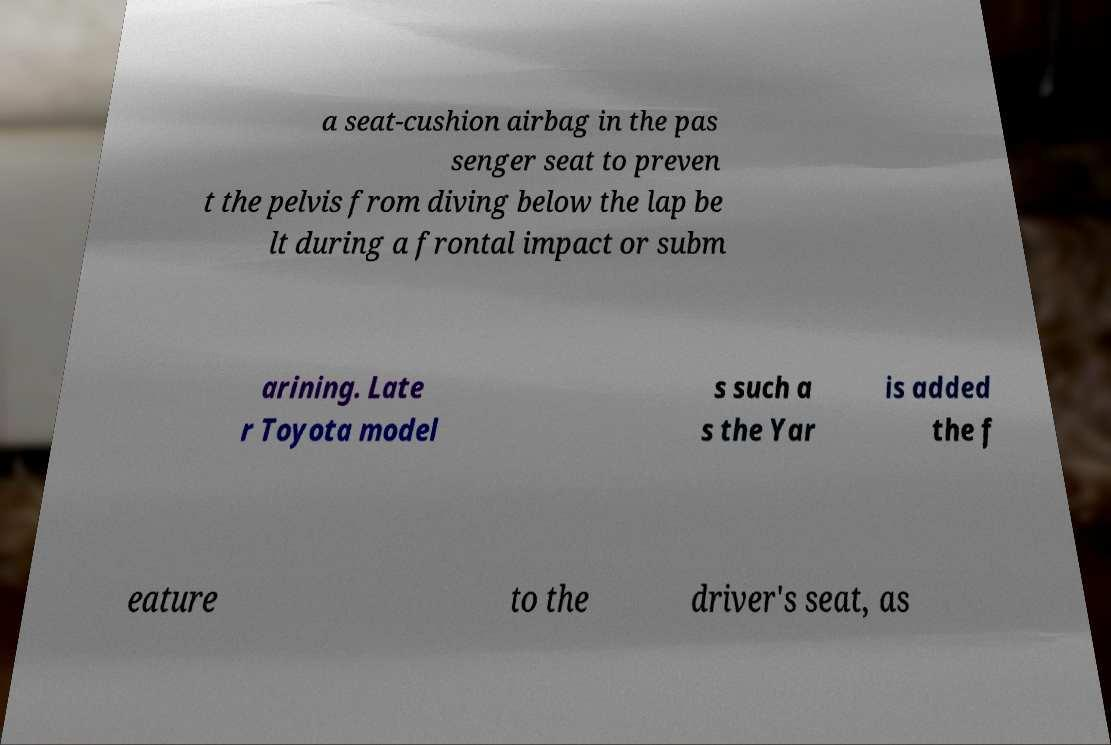What messages or text are displayed in this image? I need them in a readable, typed format. a seat-cushion airbag in the pas senger seat to preven t the pelvis from diving below the lap be lt during a frontal impact or subm arining. Late r Toyota model s such a s the Yar is added the f eature to the driver's seat, as 